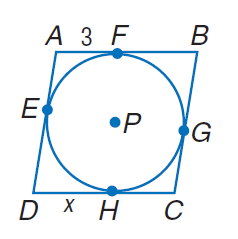Question: Rhombus A B C D is circumscribed about \odot P and has a perimeter of 32. Find x.
Choices:
A. 3
B. 4
C. 5
D. 6
Answer with the letter. Answer: C 